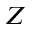Convert formula to latex. <formula><loc_0><loc_0><loc_500><loc_500>Z</formula> 